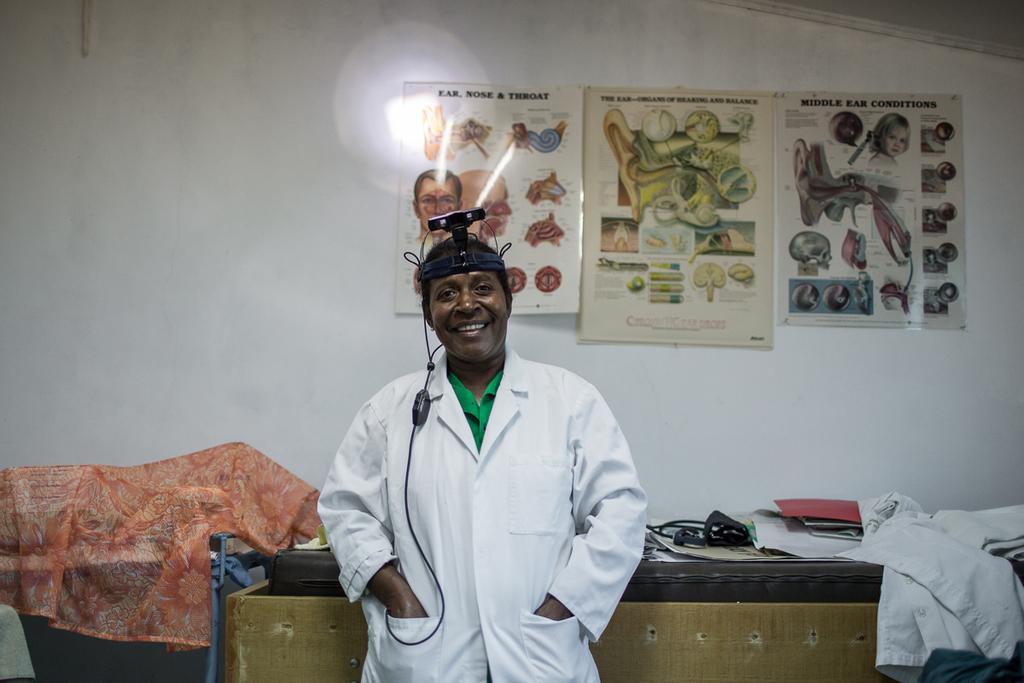In one or two sentences, can you explain what this image depicts? In this image we can see this person wearing white coat and something on his head is smiling. In the background, we can see a few things are kept on the table and the charts are attached to the wall. 